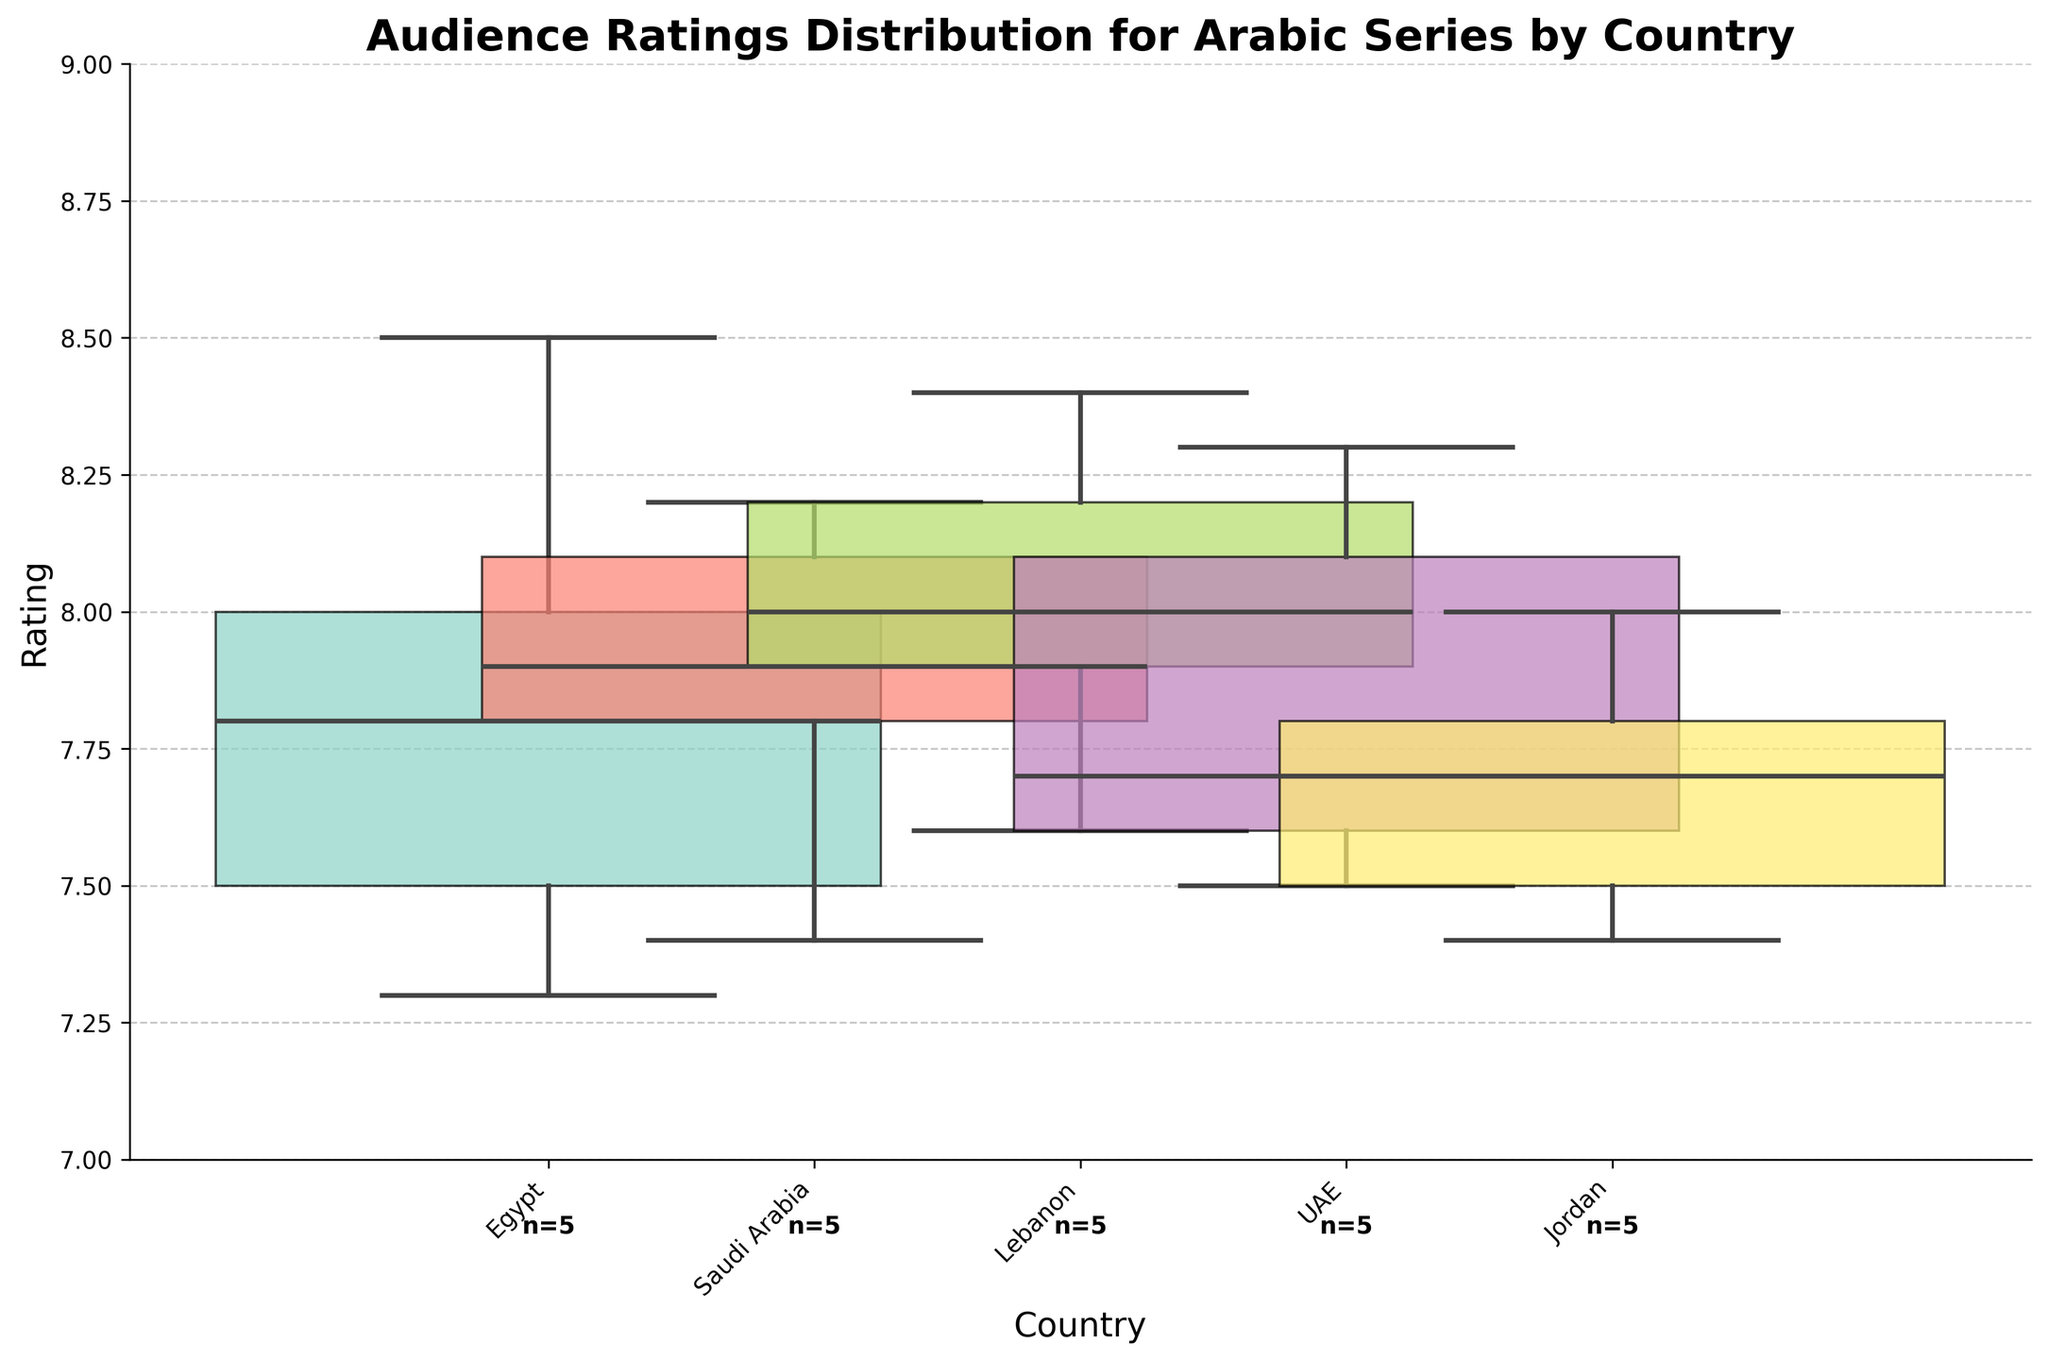How many countries are represented in the plot? Count the unique country tick labels on the x-axis.
Answer: 5 What is the median rating for series from UAE? Identify the median line within the UAE boxplot on the y-axis.
Answer: 7.7 Which country has the widest range of audience ratings? Compare the length of the whiskers (whisker length shows rating range) across all boxplots.
Answer: Egypt Are there any countries where all series have a rating above 8? Check the minimum whisker value of each country's boxplot; no whisker should fall below 8.
Answer: No Which country has the highest median rating? Locate the country whose boxplot median line is at the highest point on the y-axis.
Answer: UAE Which country has the narrowest interquartile range (IQR)? Compare the height of the boxes (from Q1 to Q3) for each country.
Answer: Jordan Which country has the most series represented in the plot? Look below each country's boxplot for the count annotation (n=).
Answer: Egypt What is the general trend in ratings among all countries? Evaluate the placement of medians and ranges; ratings generally fall between 7.4 and 8.3, observing where boxplots are centered.
Answer: 7.4 to 8.3 Which country has the least variability in ratings? Compare the spread of data points (length of whiskers and size of box) for each country.
Answer: Jordan 